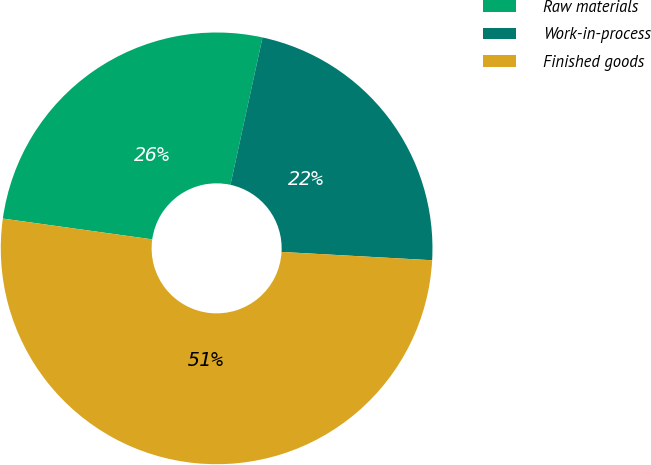Convert chart. <chart><loc_0><loc_0><loc_500><loc_500><pie_chart><fcel>Raw materials<fcel>Work-in-process<fcel>Finished goods<nl><fcel>26.21%<fcel>22.47%<fcel>51.33%<nl></chart> 